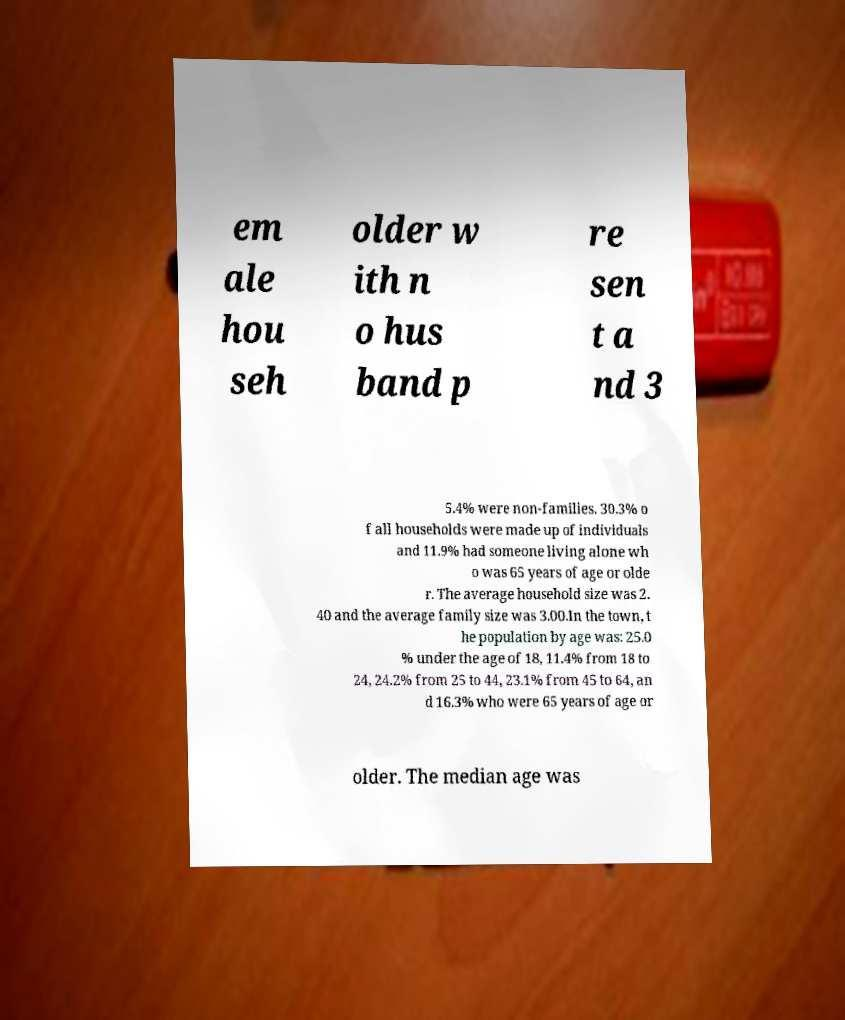Could you assist in decoding the text presented in this image and type it out clearly? em ale hou seh older w ith n o hus band p re sen t a nd 3 5.4% were non-families. 30.3% o f all households were made up of individuals and 11.9% had someone living alone wh o was 65 years of age or olde r. The average household size was 2. 40 and the average family size was 3.00.In the town, t he population by age was: 25.0 % under the age of 18, 11.4% from 18 to 24, 24.2% from 25 to 44, 23.1% from 45 to 64, an d 16.3% who were 65 years of age or older. The median age was 